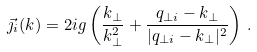Convert formula to latex. <formula><loc_0><loc_0><loc_500><loc_500>\vec { \jmath } _ { i } ( k ) = 2 i g \left ( \frac { { k } _ { \perp } } { k _ { \perp } ^ { 2 } } + \frac { { q } _ { \perp i } - { k } _ { \perp } } { | { q } _ { \perp i } - { k } _ { \perp } | ^ { 2 } } \right ) \, .</formula> 